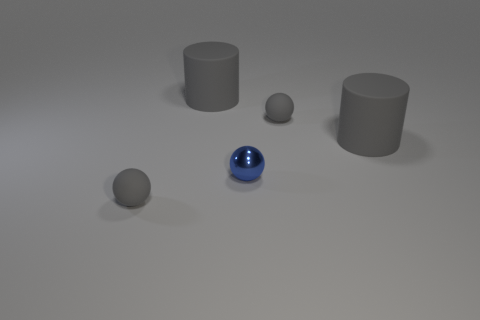Does the blue object have the same size as the gray cylinder to the left of the metal object?
Your response must be concise. No. The gray object that is both left of the tiny blue ball and behind the small blue metal object is made of what material?
Your response must be concise. Rubber. What is the big gray thing behind the small gray rubber sphere right of the blue metallic thing made of?
Offer a terse response. Rubber. What number of objects have the same material as the tiny blue sphere?
Make the answer very short. 0. How many matte things are the same color as the metallic thing?
Give a very brief answer. 0. What number of objects are either tiny gray rubber things that are in front of the blue shiny object or gray things behind the shiny sphere?
Ensure brevity in your answer.  4. Is the number of blue shiny spheres in front of the blue metallic sphere less than the number of blue things?
Offer a very short reply. Yes. Is there a gray ball that has the same size as the blue metal sphere?
Your answer should be very brief. Yes. The metal sphere is what color?
Keep it short and to the point. Blue. How many objects are small gray objects or big gray objects?
Ensure brevity in your answer.  4. 